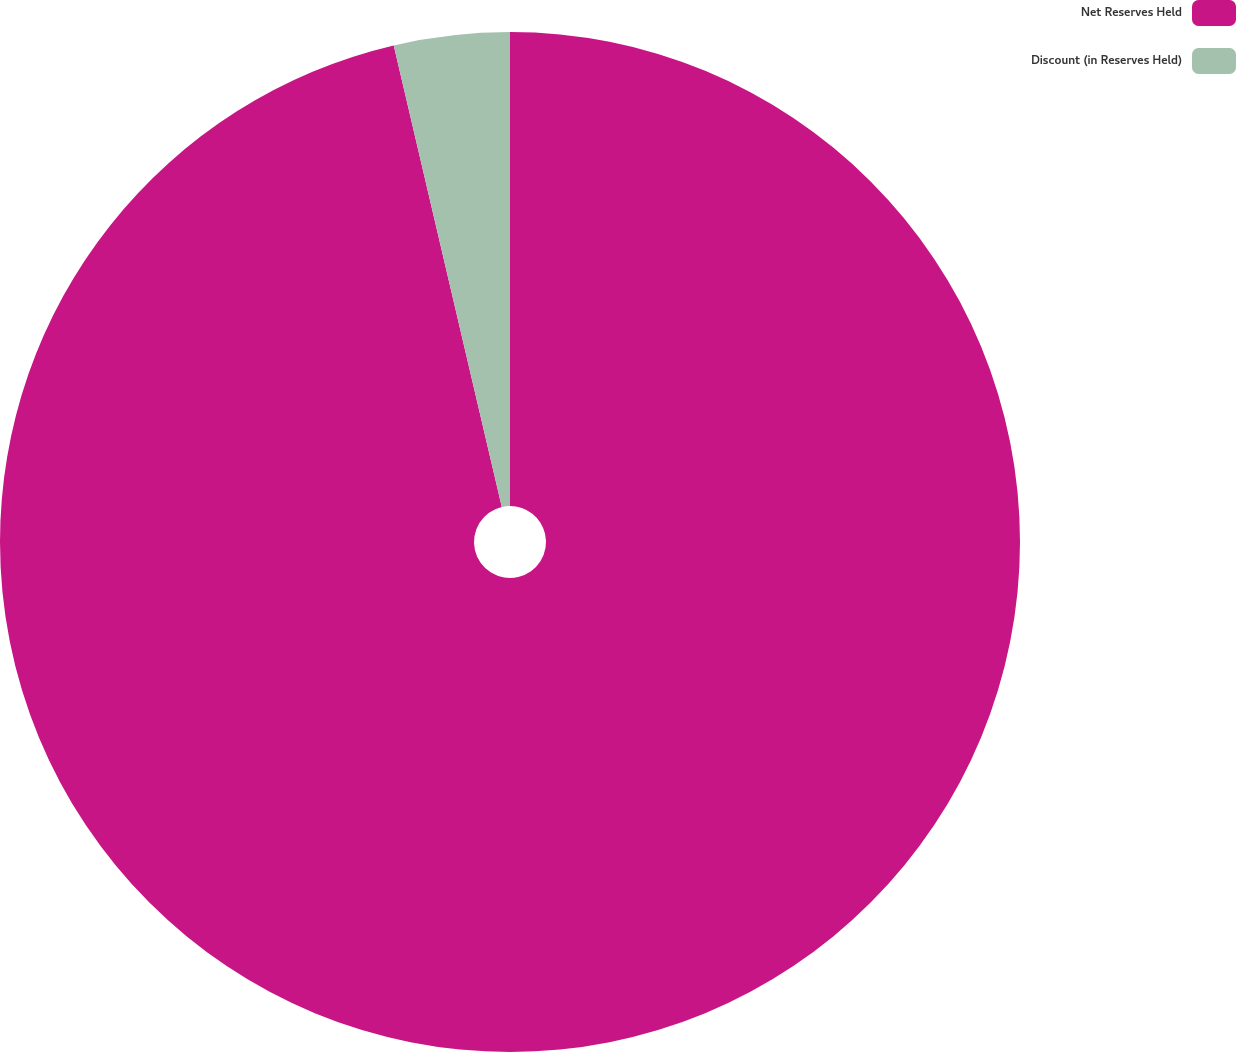<chart> <loc_0><loc_0><loc_500><loc_500><pie_chart><fcel>Net Reserves Held<fcel>Discount (in Reserves Held)<nl><fcel>96.34%<fcel>3.66%<nl></chart> 